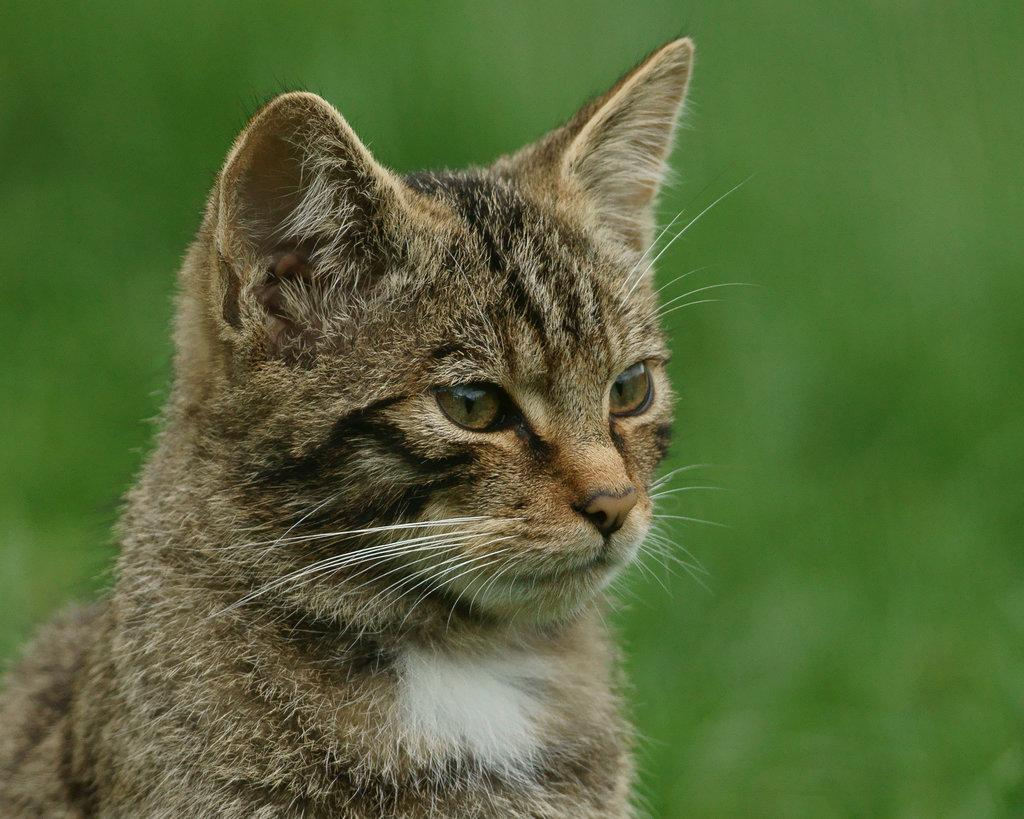What type of animal is in the image? There is a cat in the image. What is the cat doing in the image? The cat is looking at something. What color is the background of the image? The background of the image is green. How is the background of the image depicted? The background of the image is blurred. What type of sweater is the cat wearing in the image? There is no sweater present in the image, as the cat is not wearing any clothing. 